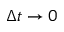<formula> <loc_0><loc_0><loc_500><loc_500>\Delta t \rightarrow 0</formula> 